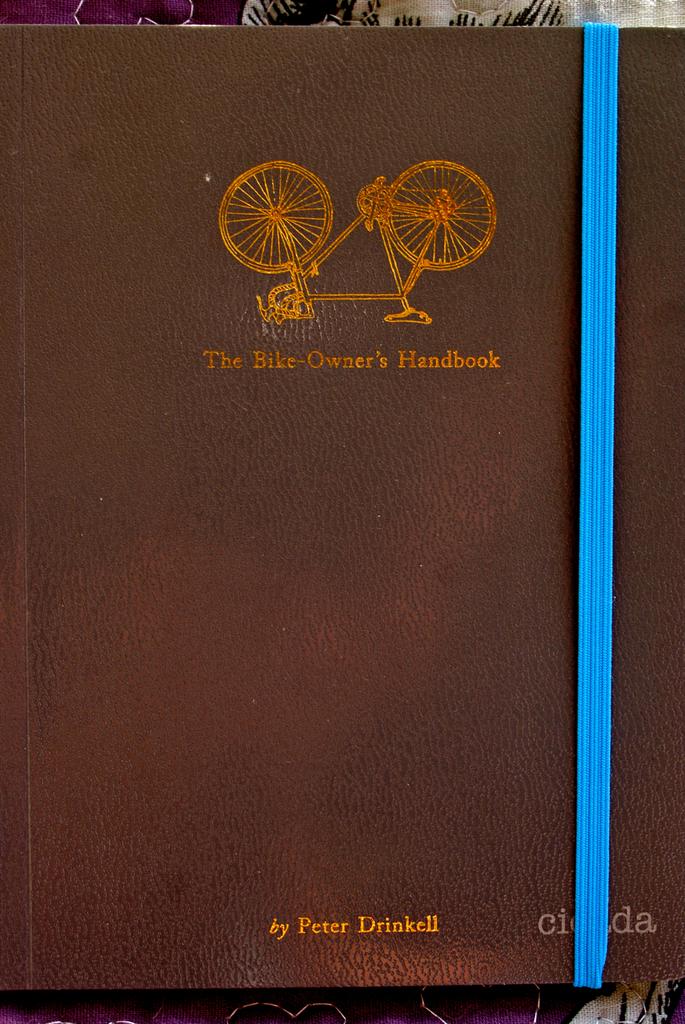Who is the author of the book?
Offer a terse response. Peter drinkell. What is the title of the book?
Keep it short and to the point. The bike-owner's handbook. 